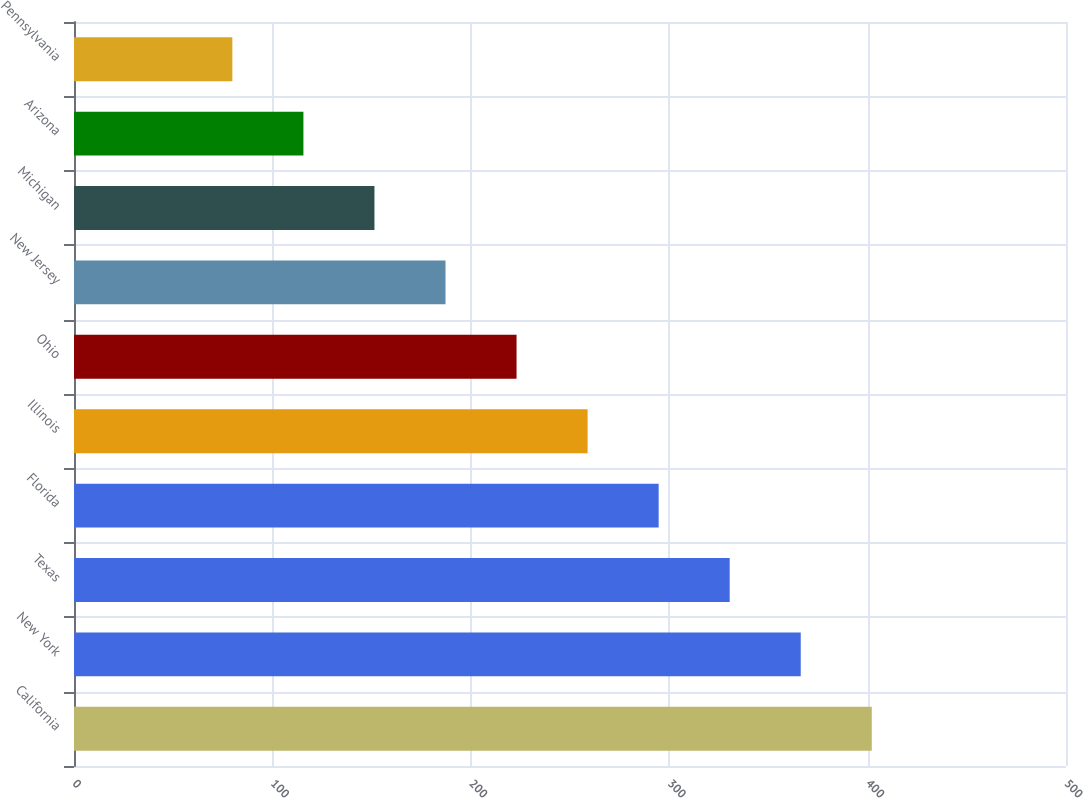Convert chart to OTSL. <chart><loc_0><loc_0><loc_500><loc_500><bar_chart><fcel>California<fcel>New York<fcel>Texas<fcel>Florida<fcel>Illinois<fcel>Ohio<fcel>New Jersey<fcel>Michigan<fcel>Arizona<fcel>Pennsylvania<nl><fcel>402.11<fcel>366.3<fcel>330.49<fcel>294.68<fcel>258.87<fcel>223.06<fcel>187.25<fcel>151.44<fcel>115.63<fcel>79.82<nl></chart> 